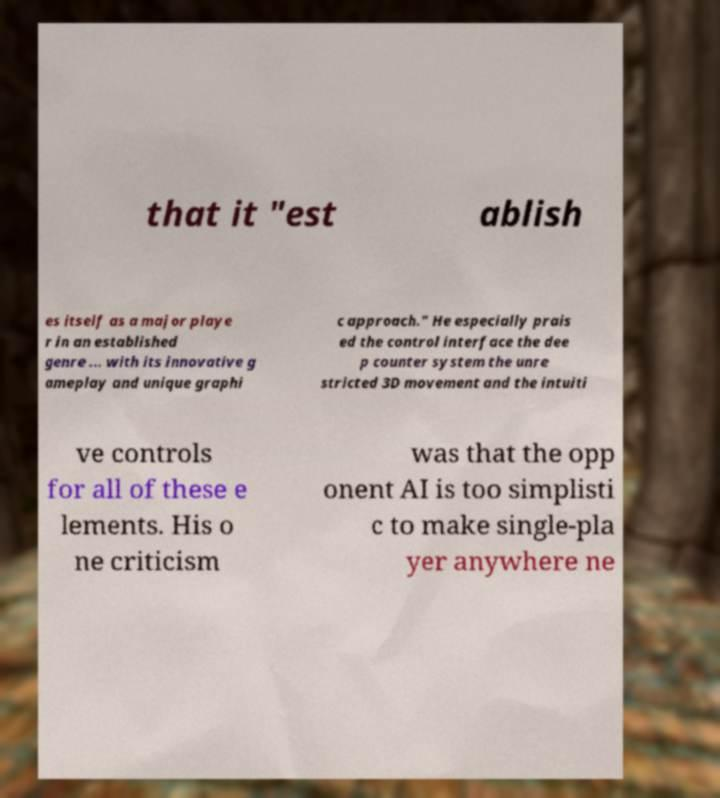For documentation purposes, I need the text within this image transcribed. Could you provide that? that it "est ablish es itself as a major playe r in an established genre ... with its innovative g ameplay and unique graphi c approach." He especially prais ed the control interface the dee p counter system the unre stricted 3D movement and the intuiti ve controls for all of these e lements. His o ne criticism was that the opp onent AI is too simplisti c to make single-pla yer anywhere ne 